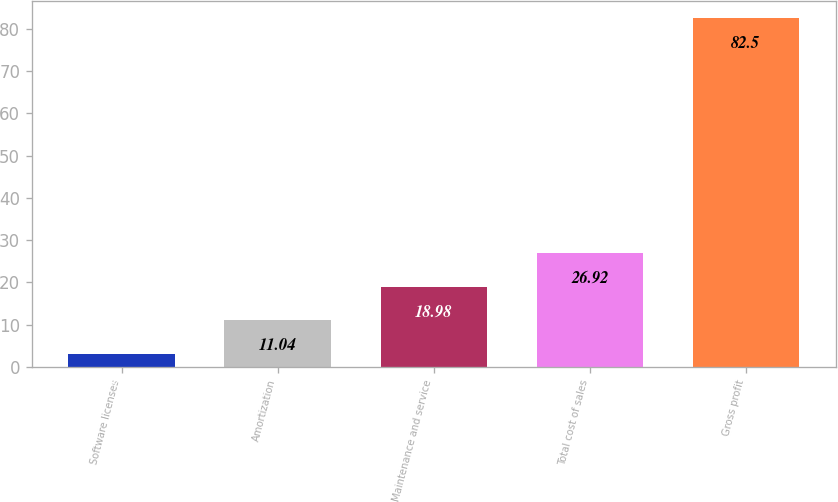Convert chart to OTSL. <chart><loc_0><loc_0><loc_500><loc_500><bar_chart><fcel>Software licenses<fcel>Amortization<fcel>Maintenance and service<fcel>Total cost of sales<fcel>Gross profit<nl><fcel>3.1<fcel>11.04<fcel>18.98<fcel>26.92<fcel>82.5<nl></chart> 